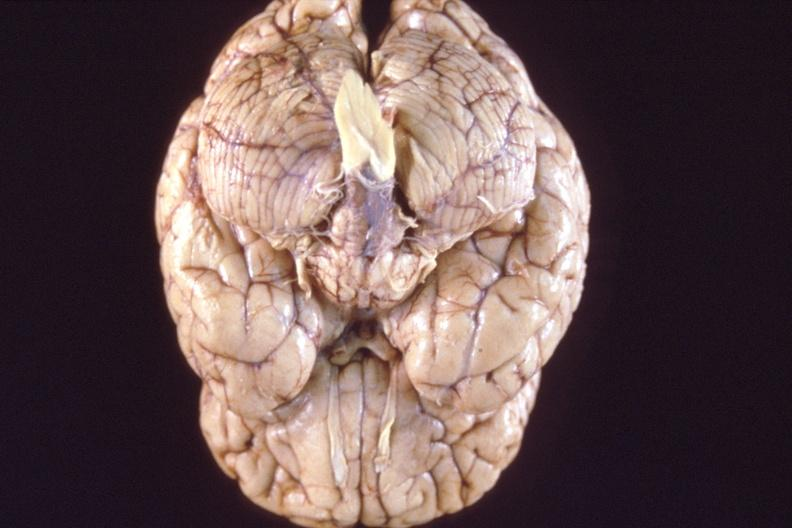what does this image show?
Answer the question using a single word or phrase. Brain 